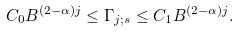Convert formula to latex. <formula><loc_0><loc_0><loc_500><loc_500>C _ { 0 } B ^ { \left ( 2 - \alpha \right ) j } \leq \Gamma _ { j ; s } \leq C _ { 1 } B ^ { \left ( 2 - \alpha \right ) j } .</formula> 